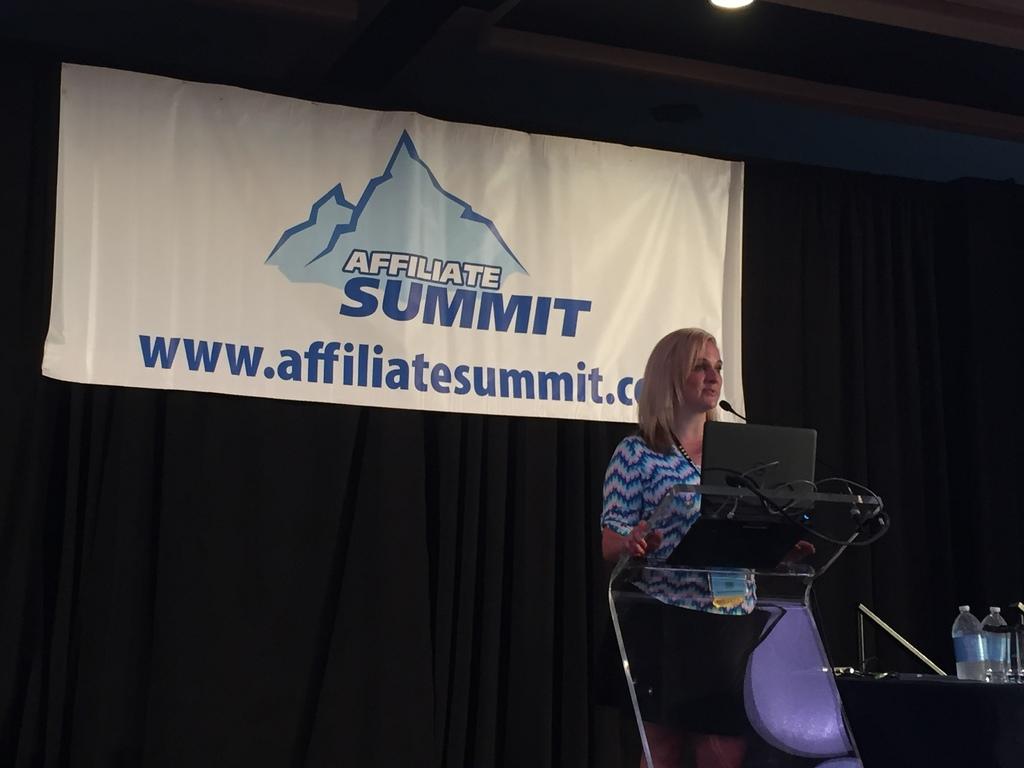What is the companies name?
Give a very brief answer. Affiliate summit. 